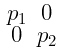Convert formula to latex. <formula><loc_0><loc_0><loc_500><loc_500>\begin{smallmatrix} p _ { 1 } & 0 \\ 0 & p _ { 2 } \end{smallmatrix}</formula> 